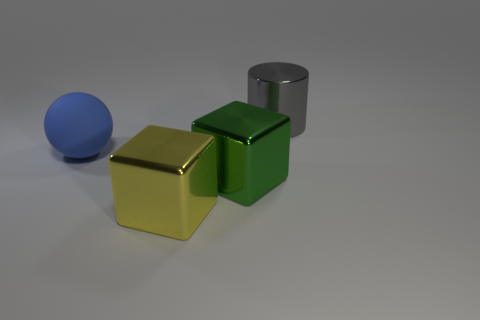Is the cube right of the yellow cube made of the same material as the cylinder on the right side of the big yellow metal thing?
Your answer should be very brief. Yes. What shape is the green metal thing that is the same size as the blue matte thing?
Make the answer very short. Cube. Is the number of large cyan metallic things less than the number of big metal cylinders?
Offer a very short reply. Yes. Are there any objects that are in front of the large metal thing that is behind the large rubber thing?
Make the answer very short. Yes. There is a thing to the left of the metallic object in front of the green metal thing; are there any large yellow blocks on the right side of it?
Ensure brevity in your answer.  Yes. There is a big object that is left of the yellow shiny thing; is it the same shape as the big object that is in front of the green thing?
Make the answer very short. No. The large cylinder that is made of the same material as the yellow thing is what color?
Offer a very short reply. Gray. Is the number of large yellow blocks that are behind the big green shiny object less than the number of large gray cylinders?
Provide a succinct answer. Yes. There is a metallic block that is behind the metal cube that is to the left of the shiny block that is to the right of the yellow metallic block; what size is it?
Provide a succinct answer. Large. Is the material of the cube behind the yellow metal block the same as the cylinder?
Your response must be concise. Yes. 